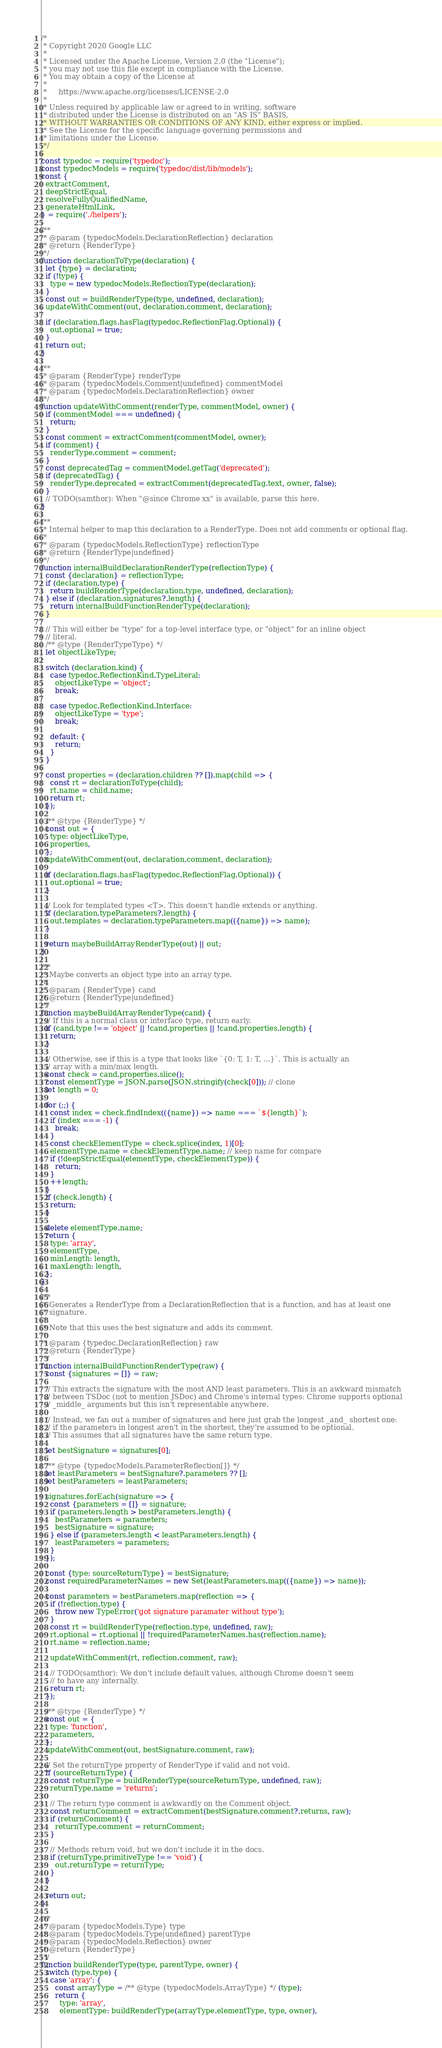<code> <loc_0><loc_0><loc_500><loc_500><_JavaScript_>/*
 * Copyright 2020 Google LLC
 *
 * Licensed under the Apache License, Version 2.0 (the "License");
 * you may not use this file except in compliance with the License.
 * You may obtain a copy of the License at
 *
 *     https://www.apache.org/licenses/LICENSE-2.0
 *
 * Unless required by applicable law or agreed to in writing, software
 * distributed under the License is distributed on an "AS IS" BASIS,
 * WITHOUT WARRANTIES OR CONDITIONS OF ANY KIND, either express or implied.
 * See the License for the specific language governing permissions and
 * limitations under the License.
 */

const typedoc = require('typedoc');
const typedocModels = require('typedoc/dist/lib/models');
const {
  extractComment,
  deepStrictEqual,
  resolveFullyQualifiedName,
  generateHtmlLink,
} = require('./helpers');

/**
 * @param {typedocModels.DeclarationReflection} declaration
 * @return {RenderType}
 */
function declarationToType(declaration) {
  let {type} = declaration;
  if (!type) {
    type = new typedocModels.ReflectionType(declaration);
  }
  const out = buildRenderType(type, undefined, declaration);
  updateWithComment(out, declaration.comment, declaration);

  if (declaration.flags.hasFlag(typedoc.ReflectionFlag.Optional)) {
    out.optional = true;
  }
  return out;
}

/**
 * @param {RenderType} renderType
 * @param {typedocModels.Comment|undefined} commentModel
 * @param {typedocModels.DeclarationReflection} owner
 */
function updateWithComment(renderType, commentModel, owner) {
  if (commentModel === undefined) {
    return;
  }
  const comment = extractComment(commentModel, owner);
  if (comment) {
    renderType.comment = comment;
  }
  const deprecatedTag = commentModel.getTag('deprecated');
  if (deprecatedTag) {
    renderType.deprecated = extractComment(deprecatedTag.text, owner, false);
  }
  // TODO(samthor): When "@since Chrome xx" is available, parse this here.
}

/**
 * Internal helper to map this declaration to a RenderType. Does not add comments or optional flag.
 *
 * @param {typedocModels.ReflectionType} reflectionType
 * @return {RenderType|undefined}
 */
function internalBuildDeclarationRenderType(reflectionType) {
  const {declaration} = reflectionType;
  if (declaration.type) {
    return buildRenderType(declaration.type, undefined, declaration);
  } else if (declaration.signatures?.length) {
    return internalBuildFunctionRenderType(declaration);
  }

  // This will either be "type" for a top-level interface type, or "object" for an inline object
  // literal.
  /** @type {RenderTypeType} */
  let objectLikeType;

  switch (declaration.kind) {
    case typedoc.ReflectionKind.TypeLiteral:
      objectLikeType = 'object';
      break;

    case typedoc.ReflectionKind.Interface:
      objectLikeType = 'type';
      break;

    default: {
      return;
    }
  }

  const properties = (declaration.children ?? []).map(child => {
    const rt = declarationToType(child);
    rt.name = child.name;
    return rt;
  });

  /** @type {RenderType} */
  const out = {
    type: objectLikeType,
    properties,
  };
  updateWithComment(out, declaration.comment, declaration);

  if (declaration.flags.hasFlag(typedoc.ReflectionFlag.Optional)) {
    out.optional = true;
  }

  // Look for templated types <T>. This doesn't handle extends or anything.
  if (declaration.typeParameters?.length) {
    out.templates = declaration.typeParameters.map(({name}) => name);
  }

  return maybeBuildArrayRenderType(out) || out;
}

/**
 * Maybe converts an object type into an array type.
 *
 * @param {RenderType} cand
 * @return {RenderType|undefined}
 */
function maybeBuildArrayRenderType(cand) {
  // If this is a normal class or interface type, return early.
  if (cand.type !== 'object' || !cand.properties || !cand.properties.length) {
    return;
  }

  // Otherwise, see if this is a type that looks like `{0: T, 1: T, ...}`. This is actually an
  // array with a min/max length.
  const check = cand.properties.slice();
  const elementType = JSON.parse(JSON.stringify(check[0])); // clone
  let length = 0;

  for (;;) {
    const index = check.findIndex(({name}) => name === `${length}`);
    if (index === -1) {
      break;
    }
    const checkElementType = check.splice(index, 1)[0];
    elementType.name = checkElementType.name; // keep name for compare
    if (!deepStrictEqual(elementType, checkElementType)) {
      return;
    }
    ++length;
  }
  if (check.length) {
    return;
  }

  delete elementType.name;
  return {
    type: 'array',
    elementType,
    minLength: length,
    maxLength: length,
  };
}

/**
 * Generates a RenderType from a DeclarationReflection that is a function, and has at least one
 * signature.
 *
 * Note that this uses the best signature and adds its comment.
 *
 * @param {typedoc.DeclarationReflection} raw
 * @return {RenderType}
 */
function internalBuildFunctionRenderType(raw) {
  const {signatures = []} = raw;

  // This extracts the signature with the most AND least parameters. This is an awkward mismatch
  // between TSDoc (not to mention JSDoc) and Chrome's internal types: Chrome supports optional
  // _middle_ arguments but this isn't representable anywhere.

  // Instead, we fan out a number of signatures and here just grab the longest _and_ shortest one:
  // if the parameters in longest aren't in the shortest, they're assumed to be optional.
  // This assumes that all signatures have the same return type.

  let bestSignature = signatures[0];

  /** @type {typedocModels.ParameterReflection[]} */
  let leastParameters = bestSignature?.parameters ?? [];
  let bestParameters = leastParameters;

  signatures.forEach(signature => {
    const {parameters = []} = signature;
    if (parameters.length > bestParameters.length) {
      bestParameters = parameters;
      bestSignature = signature;
    } else if (parameters.length < leastParameters.length) {
      leastParameters = parameters;
    }
  });

  const {type: sourceReturnType} = bestSignature;
  const requiredParameterNames = new Set(leastParameters.map(({name}) => name));

  const parameters = bestParameters.map(reflection => {
    if (!reflection.type) {
      throw new TypeError('got signature paramater without type');
    }
    const rt = buildRenderType(reflection.type, undefined, raw);
    rt.optional = rt.optional || !requiredParameterNames.has(reflection.name);
    rt.name = reflection.name;

    updateWithComment(rt, reflection.comment, raw);

    // TODO(samthor): We don't include default values, although Chrome doesn't seem
    // to have any internally.
    return rt;
  });

  /** @type {RenderType} */
  const out = {
    type: 'function',
    parameters,
  };
  updateWithComment(out, bestSignature.comment, raw);

  // Set the returnType property of RenderType if valid and not void.
  if (sourceReturnType) {
    const returnType = buildRenderType(sourceReturnType, undefined, raw);
    returnType.name = 'returns';

    // The return type comment is awkwardly on the Comment object.
    const returnComment = extractComment(bestSignature.comment?.returns, raw);
    if (returnComment) {
      returnType.comment = returnComment;
    }

    // Methods return void, but we don't include it in the docs.
    if (returnType.primitiveType !== 'void') {
      out.returnType = returnType;
    }
  }

  return out;
}

/**
 * @param {typedocModels.Type} type
 * @param {typedocModels.Type|undefined} parentType
 * @param {typedocModels.Reflection} owner
 * @return {RenderType}
 */
function buildRenderType(type, parentType, owner) {
  switch (type.type) {
    case 'array': {
      const arrayType = /** @type {typedocModels.ArrayType} */ (type);
      return {
        type: 'array',
        elementType: buildRenderType(arrayType.elementType, type, owner),</code> 